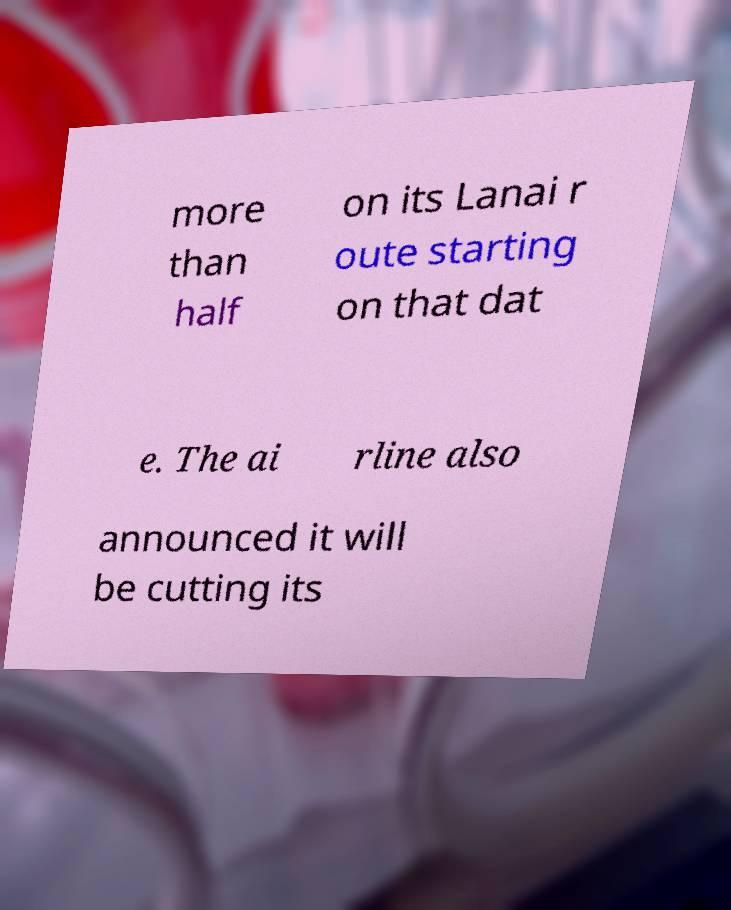Could you assist in decoding the text presented in this image and type it out clearly? more than half on its Lanai r oute starting on that dat e. The ai rline also announced it will be cutting its 